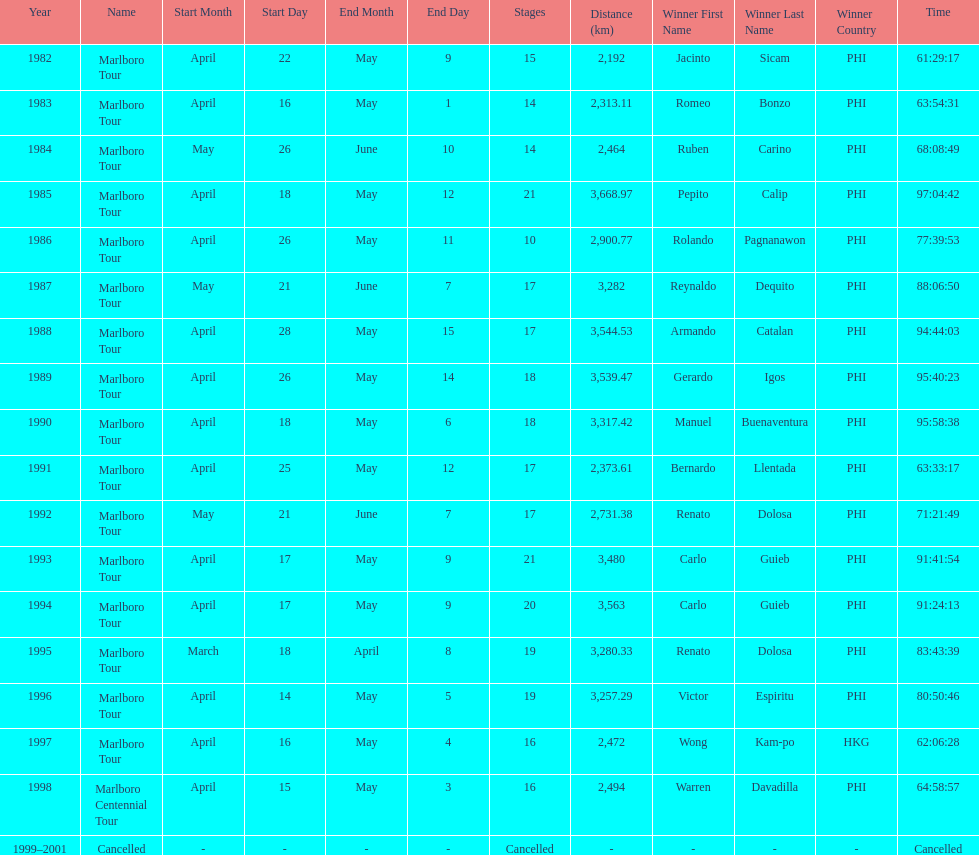How many stages was the 1982 marlboro tour? 15. Could you help me parse every detail presented in this table? {'header': ['Year', 'Name', 'Start Month', 'Start Day', 'End Month', 'End Day', 'Stages', 'Distance (km)', 'Winner First Name', 'Winner Last Name', 'Winner Country', 'Time'], 'rows': [['1982', 'Marlboro Tour', 'April', '22', 'May', '9', '15', '2,192', 'Jacinto', 'Sicam', 'PHI', '61:29:17'], ['1983', 'Marlboro Tour', 'April', '16', 'May', '1', '14', '2,313.11', 'Romeo', 'Bonzo', 'PHI', '63:54:31'], ['1984', 'Marlboro Tour', 'May', '26', 'June', '10', '14', '2,464', 'Ruben', 'Carino', 'PHI', '68:08:49'], ['1985', 'Marlboro Tour', 'April', '18', 'May', '12', '21', '3,668.97', 'Pepito', 'Calip', 'PHI', '97:04:42'], ['1986', 'Marlboro Tour', 'April', '26', 'May', '11', '10', '2,900.77', 'Rolando', 'Pagnanawon', 'PHI', '77:39:53'], ['1987', 'Marlboro Tour', 'May', '21', 'June', '7', '17', '3,282', 'Reynaldo', 'Dequito', 'PHI', '88:06:50'], ['1988', 'Marlboro Tour', 'April', '28', 'May', '15', '17', '3,544.53', 'Armando', 'Catalan', 'PHI', '94:44:03'], ['1989', 'Marlboro Tour', 'April', '26', 'May', '14', '18', '3,539.47', 'Gerardo', 'Igos', 'PHI', '95:40:23'], ['1990', 'Marlboro Tour', 'April', '18', 'May', '6', '18', '3,317.42', 'Manuel', 'Buenaventura', 'PHI', '95:58:38'], ['1991', 'Marlboro Tour', 'April', '25', 'May', '12', '17', '2,373.61', 'Bernardo', 'Llentada', 'PHI', '63:33:17'], ['1992', 'Marlboro Tour', 'May', '21', 'June', '7', '17', '2,731.38', 'Renato', 'Dolosa', 'PHI', '71:21:49'], ['1993', 'Marlboro Tour', 'April', '17', 'May', '9', '21', '3,480', 'Carlo', 'Guieb', 'PHI', '91:41:54'], ['1994', 'Marlboro Tour', 'April', '17', 'May', '9', '20', '3,563', 'Carlo', 'Guieb', 'PHI', '91:24:13'], ['1995', 'Marlboro Tour', 'March', '18', 'April', '8', '19', '3,280.33', 'Renato', 'Dolosa', 'PHI', '83:43:39'], ['1996', 'Marlboro Tour', 'April', '14', 'May', '5', '19', '3,257.29', 'Victor', 'Espiritu', 'PHI', '80:50:46'], ['1997', 'Marlboro Tour', 'April', '16', 'May', '4', '16', '2,472', 'Wong', 'Kam-po', 'HKG', '62:06:28'], ['1998', 'Marlboro Centennial Tour', 'April', '15', 'May', '3', '16', '2,494', 'Warren', 'Davadilla', 'PHI', '64:58:57'], ['1999–2001', 'Cancelled', '-', '-', '-', '-', 'Cancelled', '-', '-', '-', '-', 'Cancelled']]} 